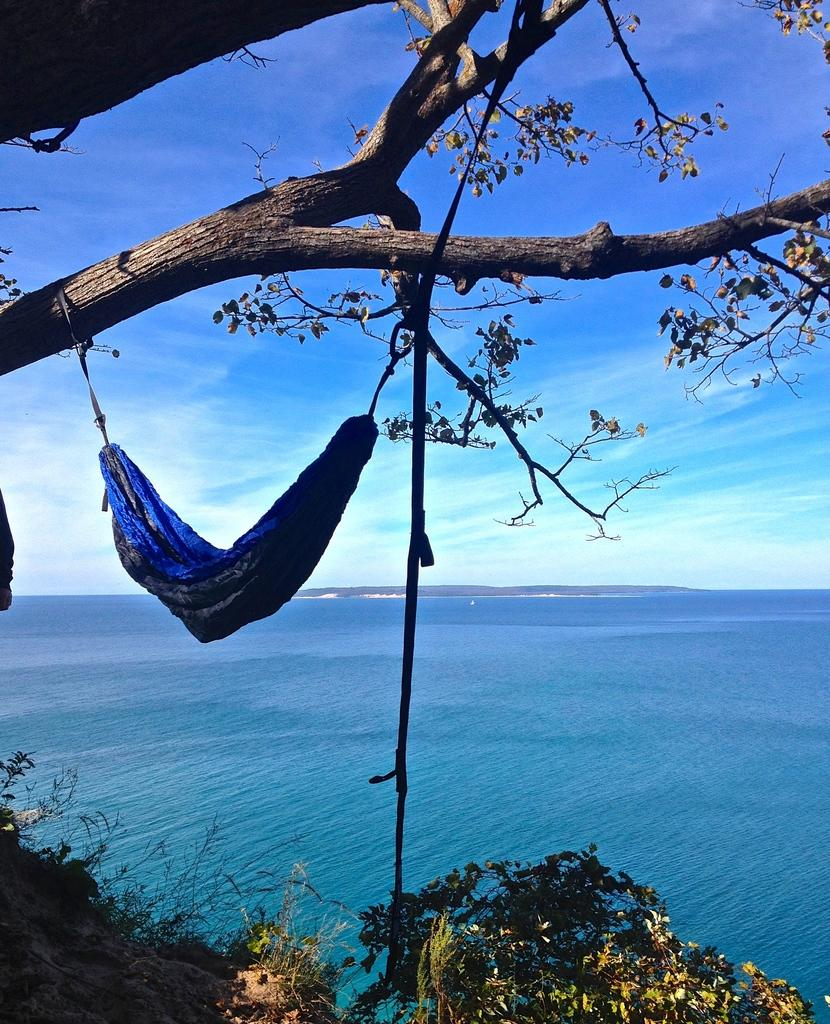What is hanging from the branch in the image? A hammock is tied to the branch in the image. What can be seen in the background of the image? Water and the sky are visible in the background of the image. What is present in the sky? Clouds are present in the sky. What type of vegetation is at the bottom of the image? There are plants at the bottom of the image. What type of nut is being served in the image? There is no nut or any indication of serving in the image. 